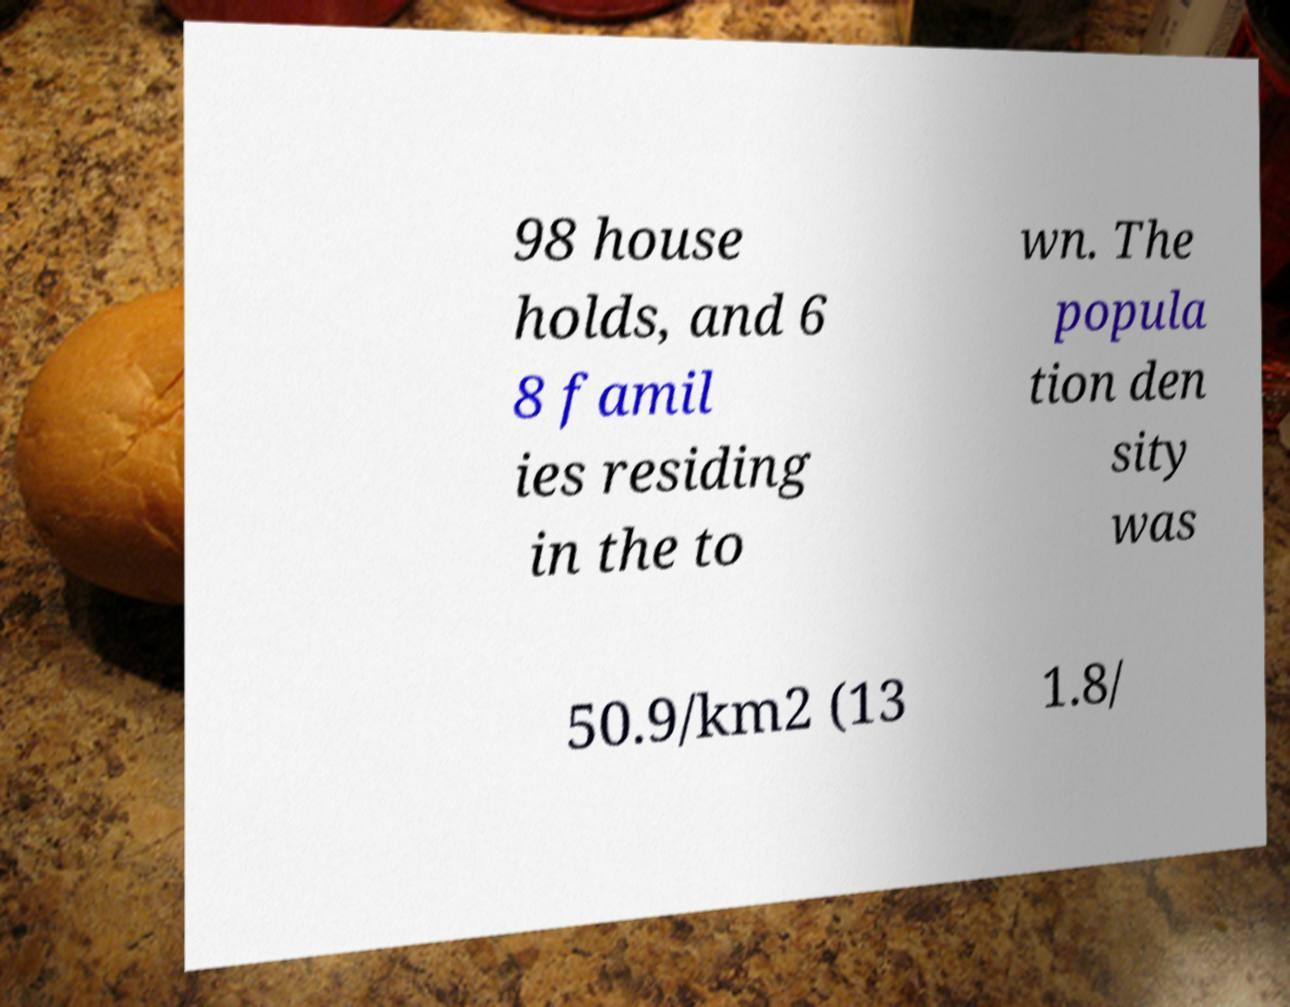Can you accurately transcribe the text from the provided image for me? 98 house holds, and 6 8 famil ies residing in the to wn. The popula tion den sity was 50.9/km2 (13 1.8/ 